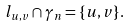Convert formula to latex. <formula><loc_0><loc_0><loc_500><loc_500>l _ { u , v } \cap \gamma _ { n } = \{ u , v \} .</formula> 